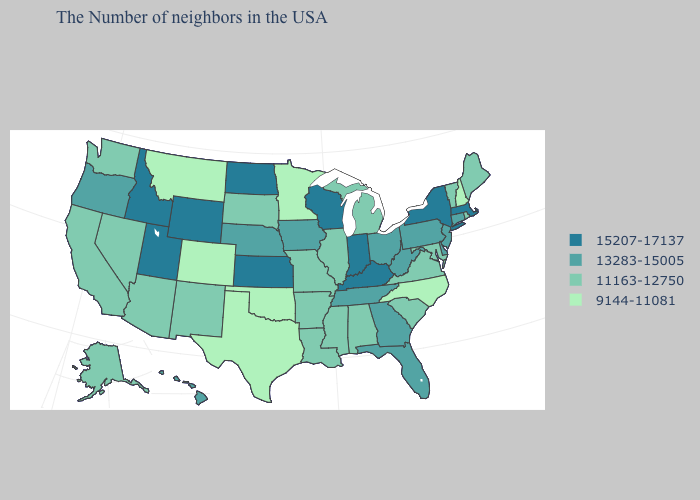Which states have the highest value in the USA?
Be succinct. Massachusetts, New York, Kentucky, Indiana, Wisconsin, Kansas, North Dakota, Wyoming, Utah, Idaho. Does Louisiana have a higher value than Texas?
Write a very short answer. Yes. How many symbols are there in the legend?
Answer briefly. 4. What is the lowest value in the Northeast?
Concise answer only. 9144-11081. Is the legend a continuous bar?
Be succinct. No. What is the value of Illinois?
Give a very brief answer. 11163-12750. What is the value of Minnesota?
Short answer required. 9144-11081. Name the states that have a value in the range 9144-11081?
Answer briefly. New Hampshire, North Carolina, Minnesota, Oklahoma, Texas, Colorado, Montana. What is the value of Virginia?
Answer briefly. 11163-12750. What is the value of Maryland?
Give a very brief answer. 11163-12750. What is the value of Pennsylvania?
Write a very short answer. 13283-15005. What is the highest value in states that border Delaware?
Keep it brief. 13283-15005. Which states have the lowest value in the USA?
Keep it brief. New Hampshire, North Carolina, Minnesota, Oklahoma, Texas, Colorado, Montana. Which states have the highest value in the USA?
Give a very brief answer. Massachusetts, New York, Kentucky, Indiana, Wisconsin, Kansas, North Dakota, Wyoming, Utah, Idaho. 